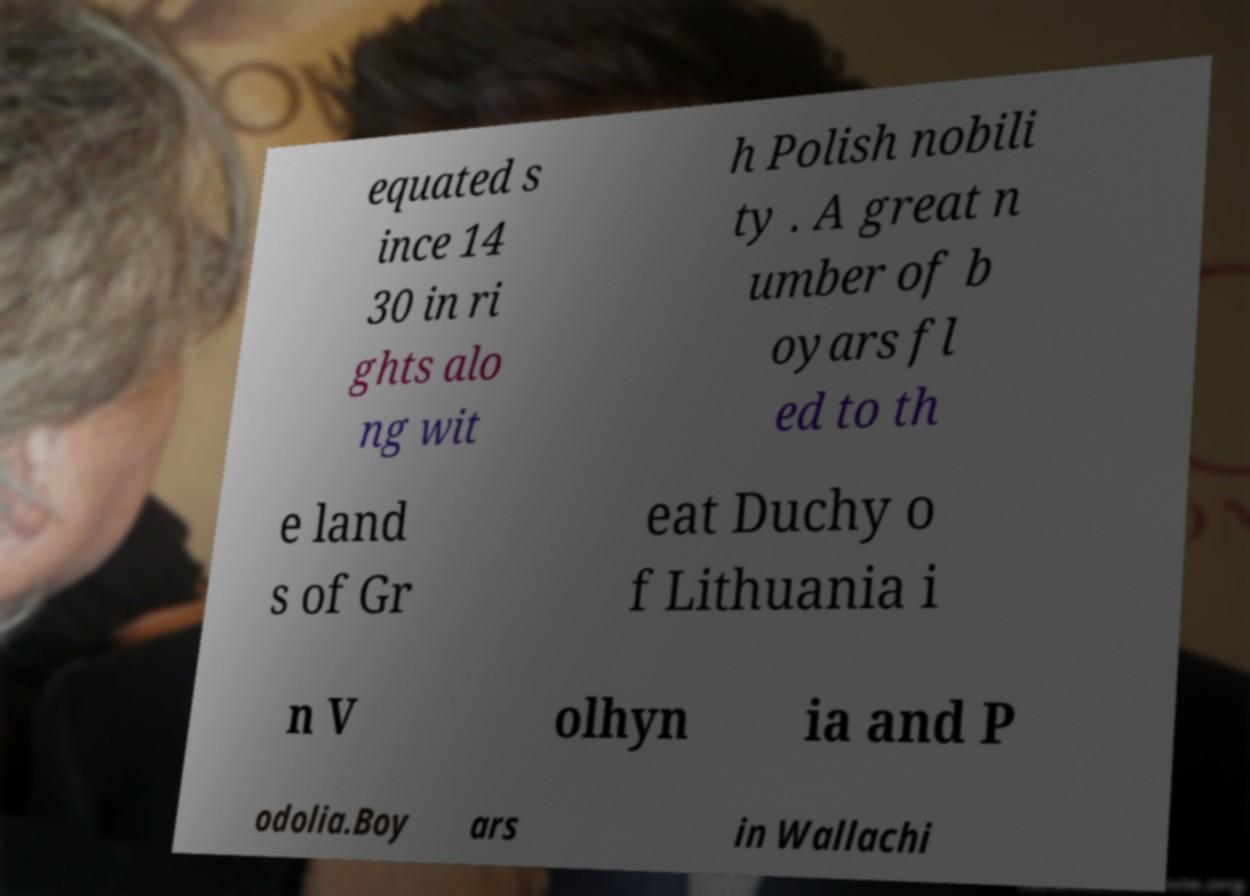For documentation purposes, I need the text within this image transcribed. Could you provide that? equated s ince 14 30 in ri ghts alo ng wit h Polish nobili ty . A great n umber of b oyars fl ed to th e land s of Gr eat Duchy o f Lithuania i n V olhyn ia and P odolia.Boy ars in Wallachi 